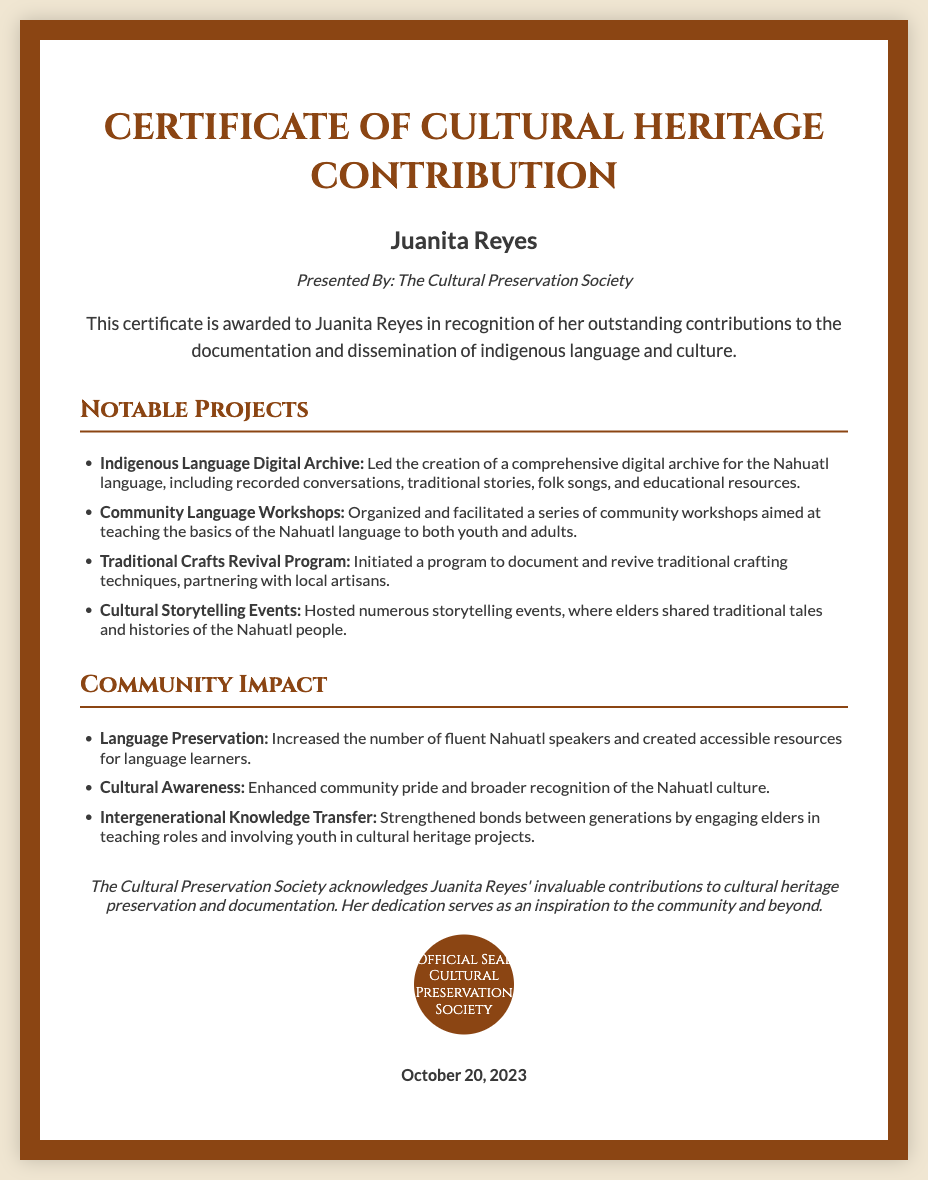What is the recipient's name? The recipient's name is prominently displayed at the top of the document as Juanita Reyes.
Answer: Juanita Reyes Who presented the certificate? The entity that presented the certificate is mentioned directly below the recipient's name as The Cultural Preservation Society.
Answer: The Cultural Preservation Society What is one of the notable projects mentioned? Several notable projects are listed; one example is the Indigenous Language Digital Archive, which is described in detail.
Answer: Indigenous Language Digital Archive When was the certificate issued? The date of issuance is mentioned at the bottom of the document as October 20, 2023.
Answer: October 20, 2023 What impact did the community experience related to language? One of the specific impacts is the increased number of fluent Nahuatl speakers, indicating a positive outcome of the efforts listed in the document.
Answer: Increased the number of fluent Nahuatl speakers What is the primary focus of the certificate? The certificate is awarded in recognition of contributions towards documenting and disseminating indigenous language and culture.
Answer: Cultural heritage preservation How many notable projects are listed in the document? The document outlines a total of four notable projects related to cultural contributions.
Answer: Four What type of events did Juanita Reyes host? The certificate mentions that she hosted cultural storytelling events, which involved sharing traditional tales and histories.
Answer: Cultural storytelling events What does the seal represent? The seal included in the certificate signifies the authority and authenticity of the Cultural Preservation Society.
Answer: Official Seal 